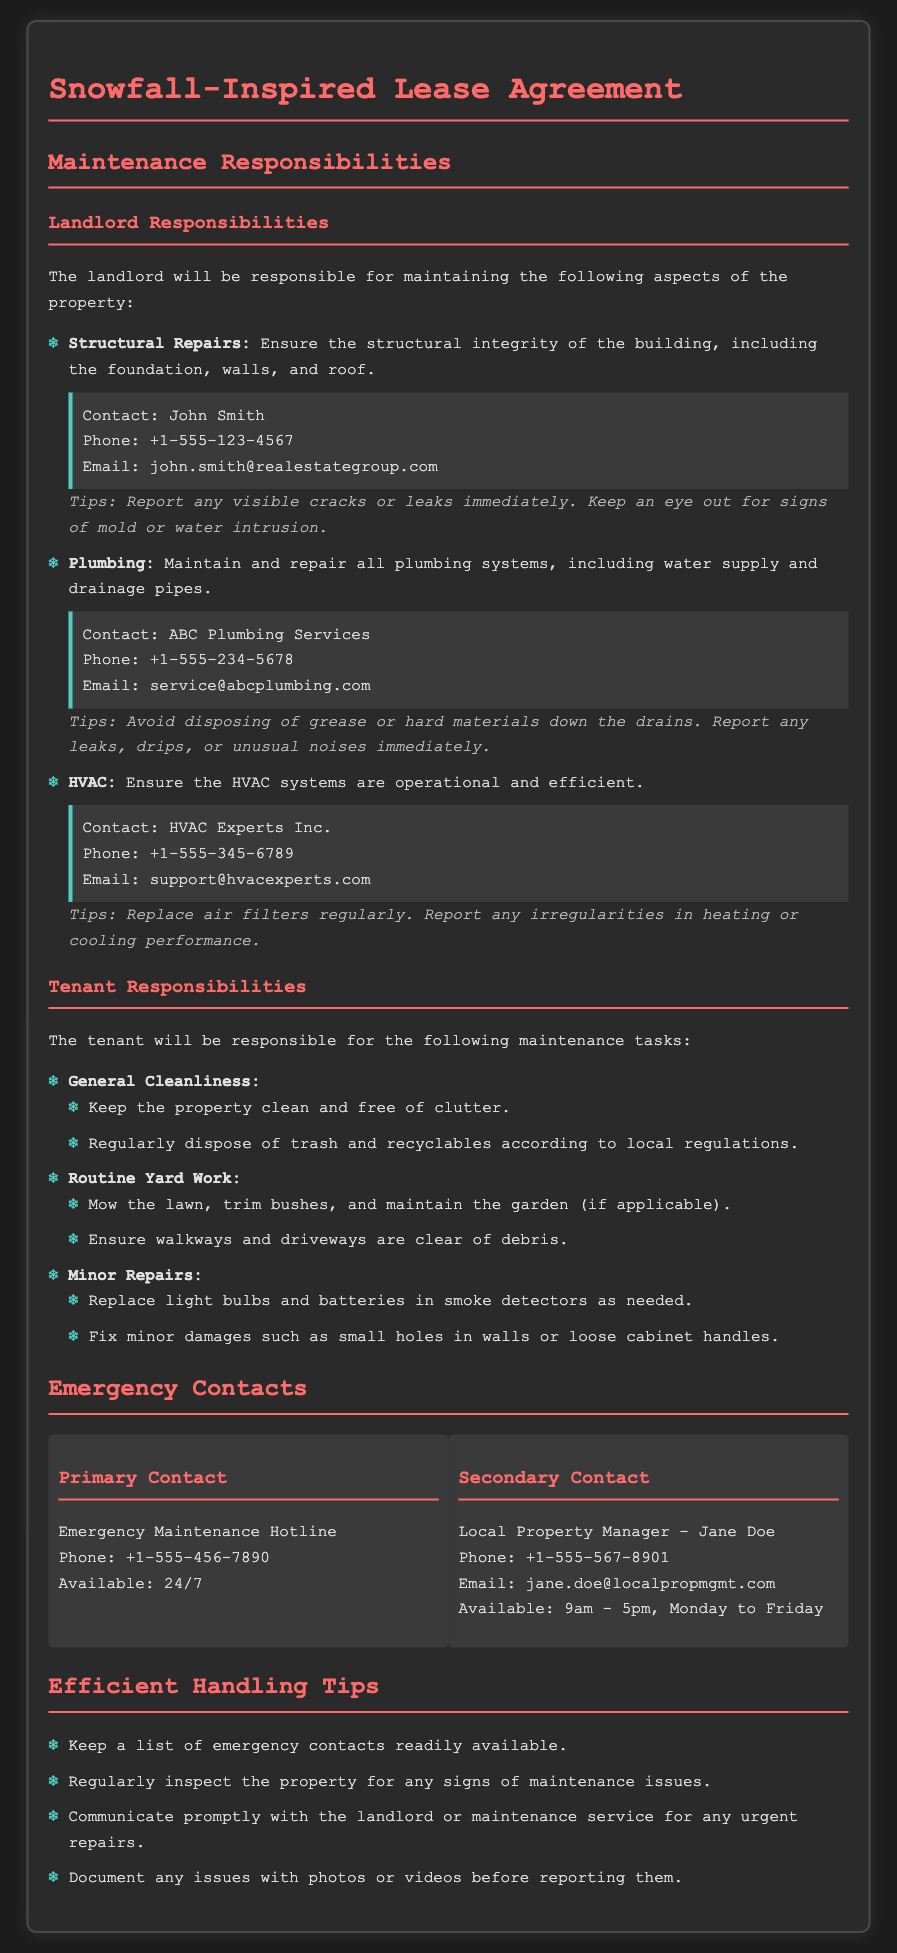What are the landlord's responsibilities? The landlord's responsibilities are listed in the document, including structural repairs, plumbing, and HVAC maintenance.
Answer: Structural Repairs, Plumbing, HVAC Who is the primary emergency contact? The primary emergency contact is specified in the emergency contacts section.
Answer: Emergency Maintenance Hotline What is the phone number for ABC Plumbing Services? The phone number for plumbing services is mentioned under the plumbing responsibilities.
Answer: +1-555-234-5678 What tips are provided for handling HVAC maintenance? The tips for HVAC maintenance are provided in the section about HVAC responsibilities.
Answer: Replace air filters regularly How often is the local property manager available? The availability of the local property manager is indicated in the emergency contacts section.
Answer: 9am - 5pm, Monday to Friday What should tenants do to prevent plumbing issues? The document includes tips for tenants to avoid plumbing problems.
Answer: Avoid disposing of grease or hard materials down the drains What maintenance task includes mowing the lawn? The specific maintenance task related to yard work is outlined in the tenant responsibilities section.
Answer: Routine Yard Work What is the email for John Smith? The email contact for John Smith is provided under landlord responsibilities.
Answer: john.smith@realestategroup.com 